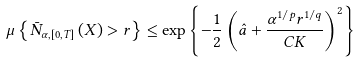<formula> <loc_0><loc_0><loc_500><loc_500>\mu \left \{ \bar { N } _ { \alpha , \left [ 0 , T \right ] } \left ( X \right ) > r \right \} \leq \exp \left \{ - \frac { 1 } { 2 } \left ( \hat { a } + \frac { \alpha ^ { 1 / p } r ^ { 1 / q } } { C K } \right ) ^ { 2 } \right \}</formula> 